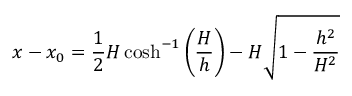<formula> <loc_0><loc_0><loc_500><loc_500>x - x _ { 0 } = { \frac { 1 } { 2 } } H \cosh ^ { - 1 } \left ( { \frac { H } { h } } \right ) - H { \sqrt { 1 - { \frac { h ^ { 2 } } { H ^ { 2 } } } } }</formula> 